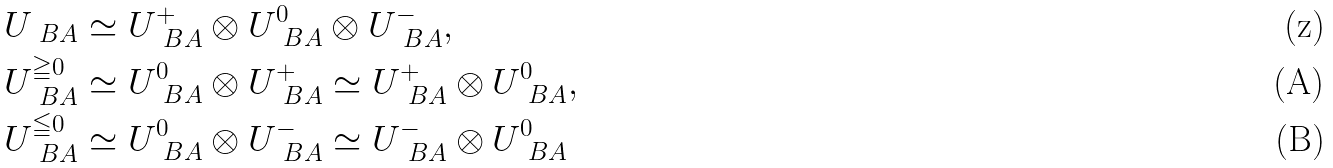<formula> <loc_0><loc_0><loc_500><loc_500>& U _ { \ B A } \simeq U _ { \ B A } ^ { + } \otimes U _ { \ B A } ^ { 0 } \otimes U _ { \ B A } ^ { - } , \\ & U _ { \ B A } ^ { \geqq 0 } \simeq U _ { \ B A } ^ { 0 } \otimes U _ { \ B A } ^ { + } \simeq U _ { \ B A } ^ { + } \otimes U _ { \ B A } ^ { 0 } , \\ & U _ { \ B A } ^ { \leqq 0 } \simeq U _ { \ B A } ^ { 0 } \otimes U _ { \ B A } ^ { - } \simeq U _ { \ B A } ^ { - } \otimes U _ { \ B A } ^ { 0 }</formula> 